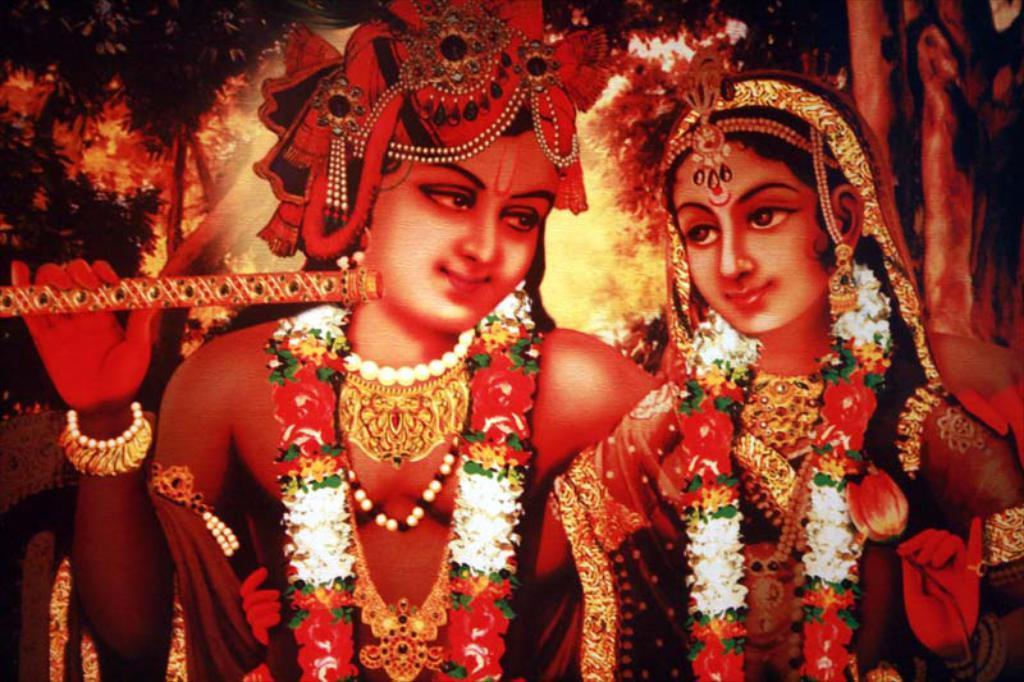How would you summarize this image in a sentence or two? This picture contains the painting of the lord Radha and Krishna who is holding a flute in his hand. They are wearing garlands. Behind them, there are trees and this picture might be a photo frame. 